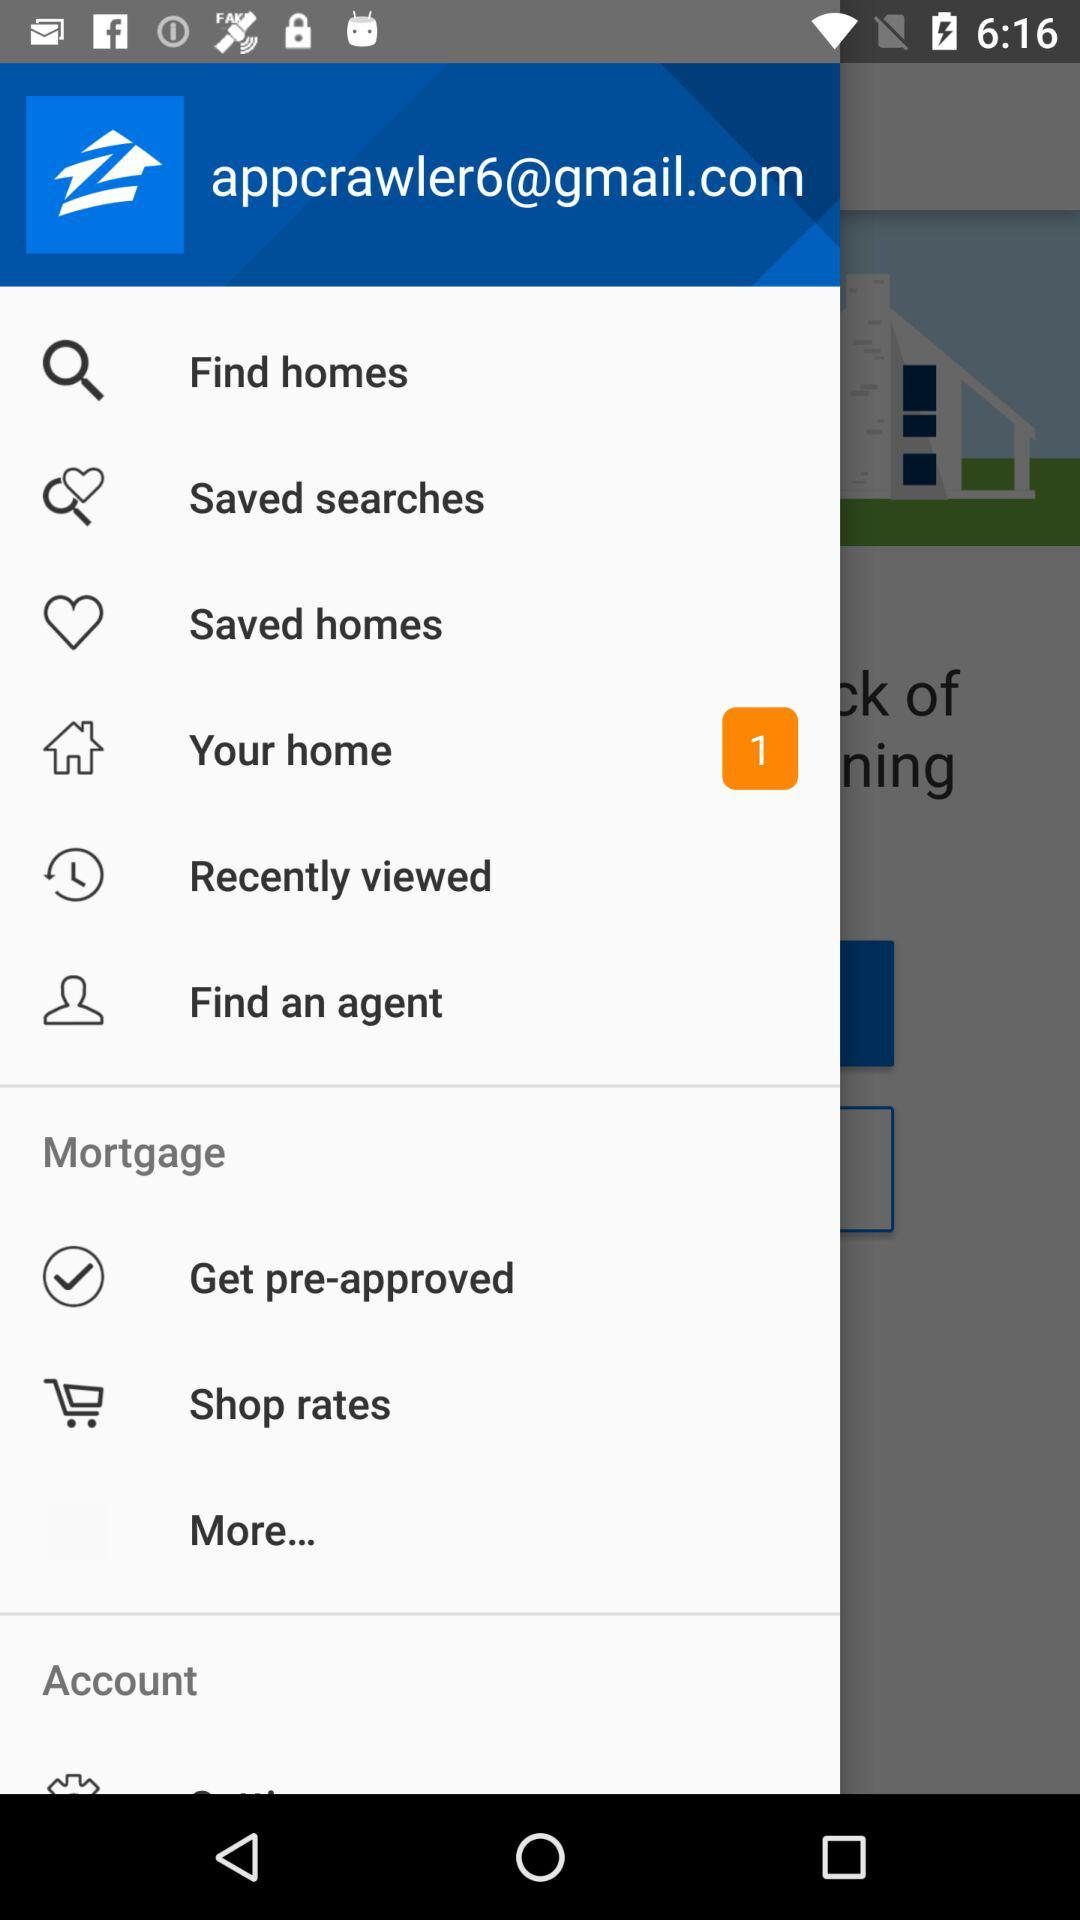What is the email address? The email address is appcrawler6@gmail.com. 